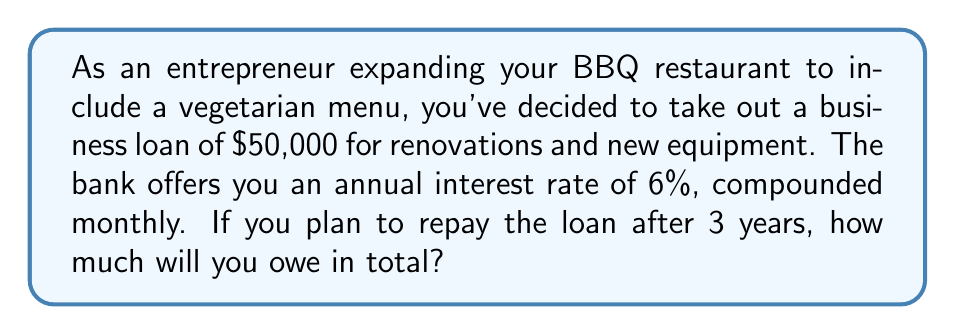Can you solve this math problem? To solve this problem, we'll use the compound interest formula:

$$A = P(1 + \frac{r}{n})^{nt}$$

Where:
$A$ = Final amount
$P$ = Principal (initial loan amount)
$r$ = Annual interest rate (as a decimal)
$n$ = Number of times interest is compounded per year
$t$ = Number of years

Given:
$P = \$50,000$
$r = 0.06$ (6% expressed as a decimal)
$n = 12$ (compounded monthly)
$t = 3$ years

Let's substitute these values into the formula:

$$A = 50000(1 + \frac{0.06}{12})^{12 \cdot 3}$$

$$A = 50000(1 + 0.005)^{36}$$

$$A = 50000(1.005)^{36}$$

Using a calculator or computer:

$$A = 50000 \cdot 1.1963652443$$

$$A = 59818.26$$

Rounding to the nearest cent:

$$A = \$59,818.26$$
Answer: $59,818.26 